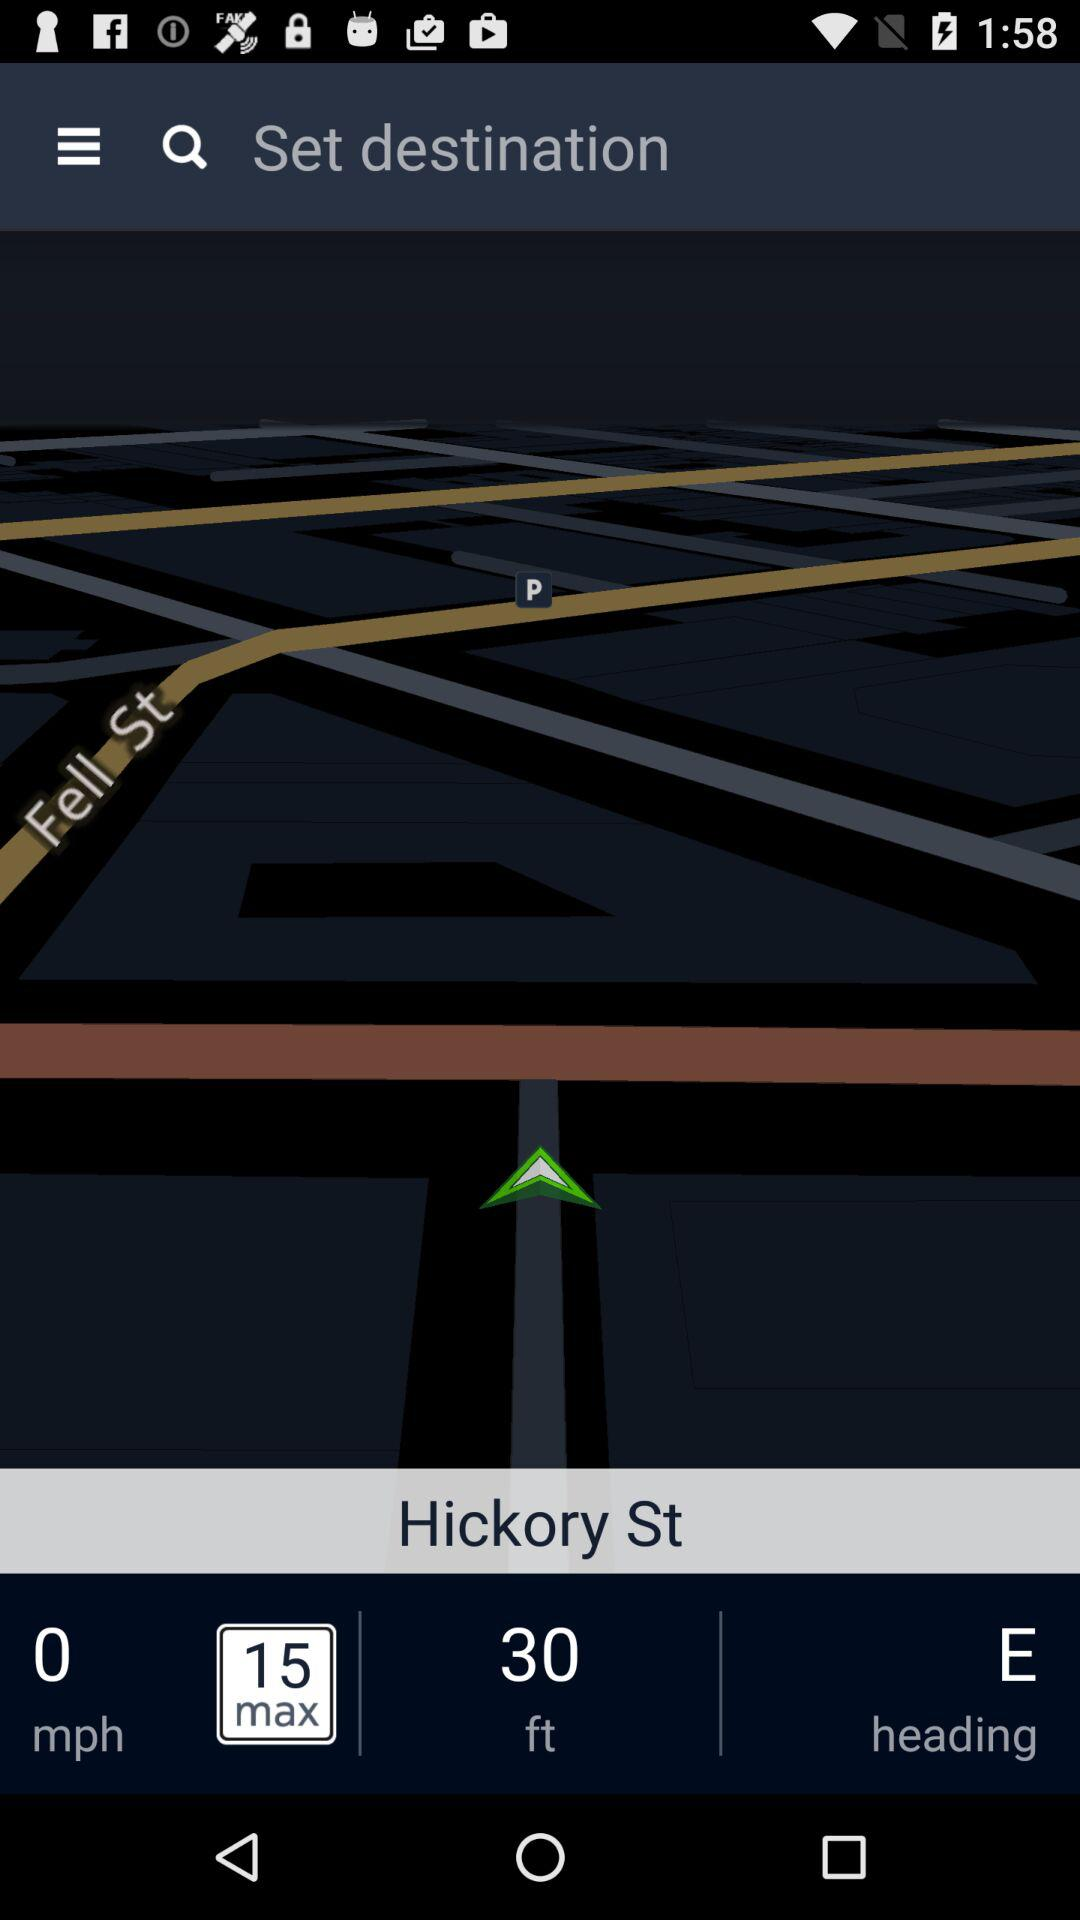What is the heading of the vehicle?
Answer the question using a single word or phrase. E 